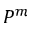Convert formula to latex. <formula><loc_0><loc_0><loc_500><loc_500>P ^ { m }</formula> 